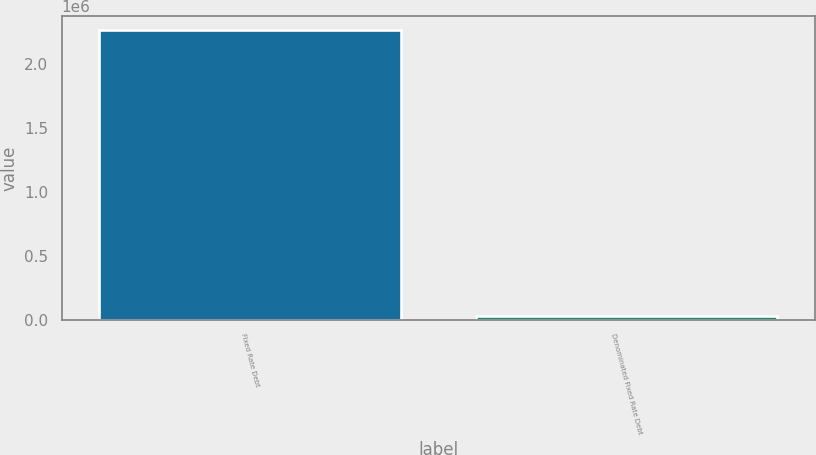<chart> <loc_0><loc_0><loc_500><loc_500><bar_chart><fcel>Fixed Rate Debt<fcel>Denominated Fixed Rate Debt<nl><fcel>2.26296e+06<fcel>26851<nl></chart> 